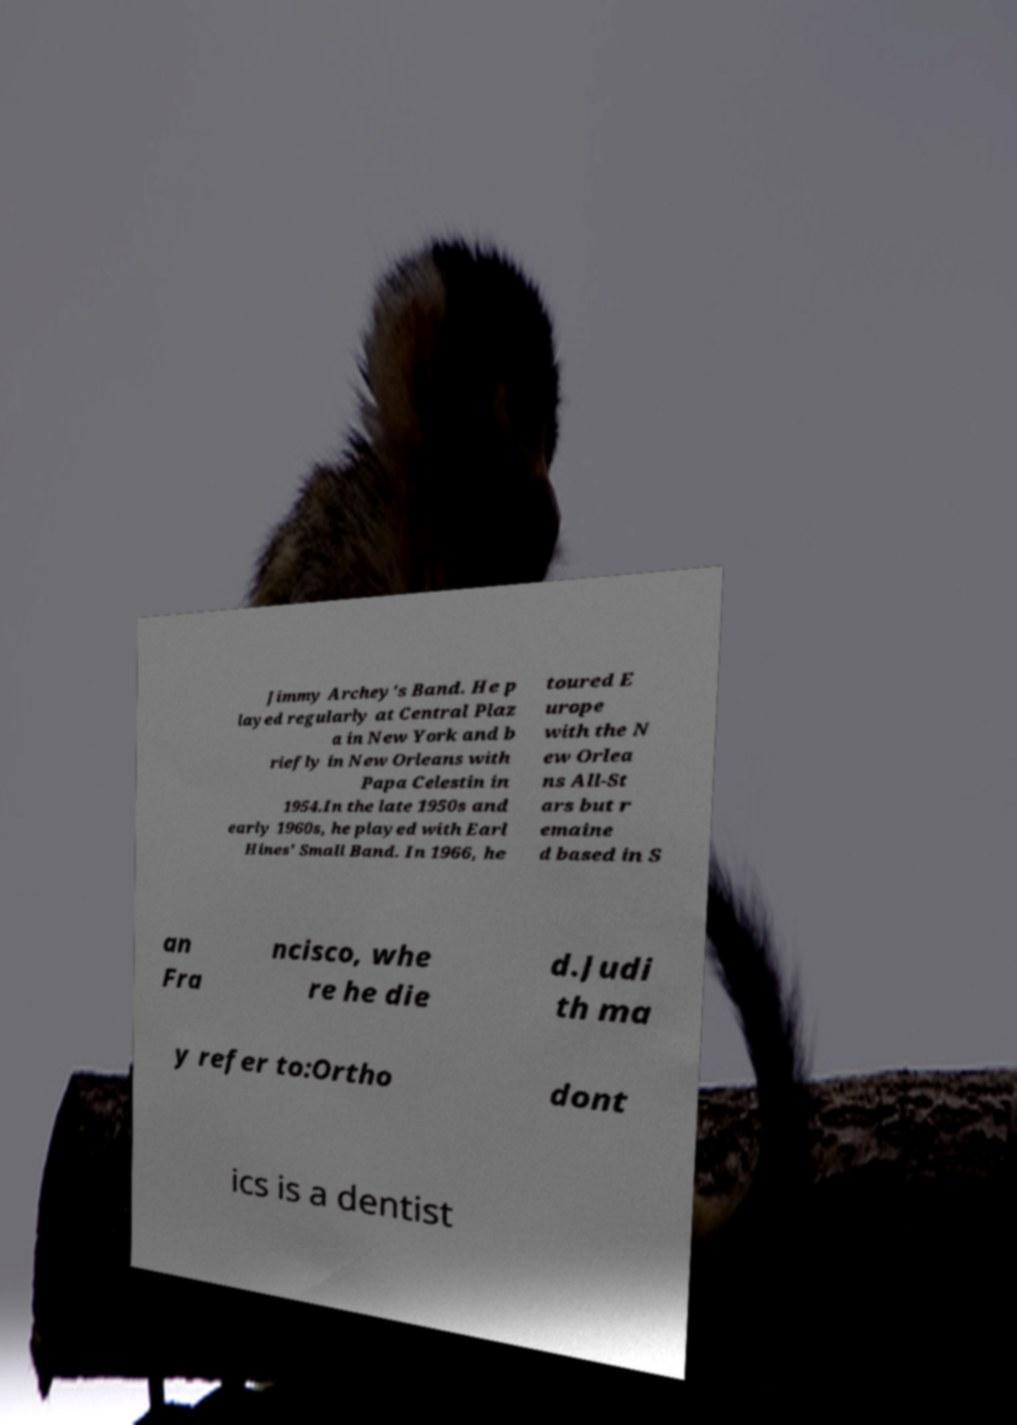I need the written content from this picture converted into text. Can you do that? Jimmy Archey's Band. He p layed regularly at Central Plaz a in New York and b riefly in New Orleans with Papa Celestin in 1954.In the late 1950s and early 1960s, he played with Earl Hines' Small Band. In 1966, he toured E urope with the N ew Orlea ns All-St ars but r emaine d based in S an Fra ncisco, whe re he die d.Judi th ma y refer to:Ortho dont ics is a dentist 